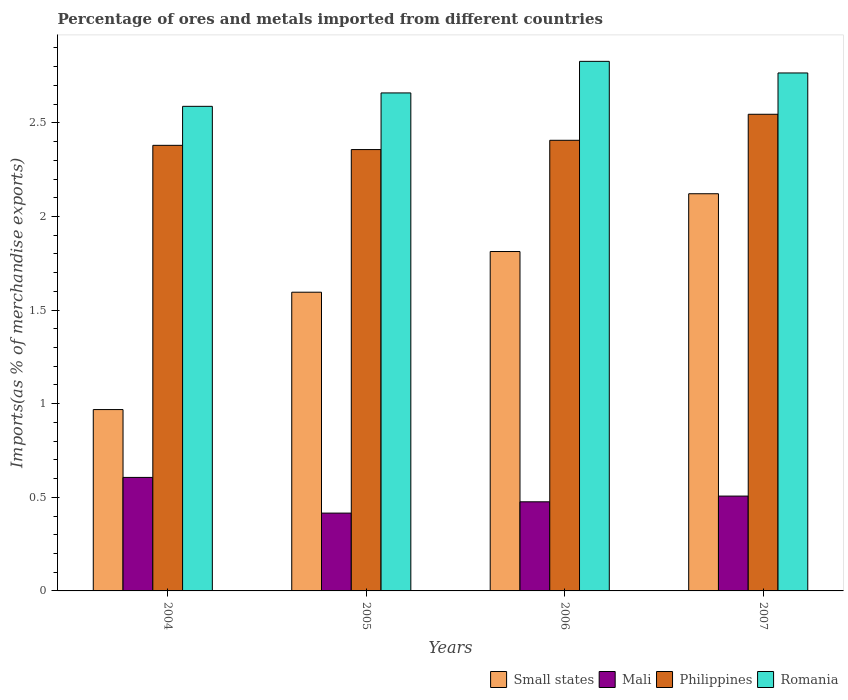How many groups of bars are there?
Ensure brevity in your answer.  4. How many bars are there on the 2nd tick from the left?
Ensure brevity in your answer.  4. What is the percentage of imports to different countries in Small states in 2005?
Ensure brevity in your answer.  1.6. Across all years, what is the maximum percentage of imports to different countries in Philippines?
Give a very brief answer. 2.55. Across all years, what is the minimum percentage of imports to different countries in Romania?
Offer a terse response. 2.59. In which year was the percentage of imports to different countries in Small states maximum?
Provide a succinct answer. 2007. In which year was the percentage of imports to different countries in Mali minimum?
Your answer should be very brief. 2005. What is the total percentage of imports to different countries in Philippines in the graph?
Your answer should be compact. 9.69. What is the difference between the percentage of imports to different countries in Philippines in 2004 and that in 2005?
Provide a succinct answer. 0.02. What is the difference between the percentage of imports to different countries in Small states in 2006 and the percentage of imports to different countries in Mali in 2004?
Provide a succinct answer. 1.21. What is the average percentage of imports to different countries in Mali per year?
Provide a short and direct response. 0.5. In the year 2007, what is the difference between the percentage of imports to different countries in Mali and percentage of imports to different countries in Philippines?
Ensure brevity in your answer.  -2.04. What is the ratio of the percentage of imports to different countries in Romania in 2005 to that in 2006?
Your answer should be compact. 0.94. Is the difference between the percentage of imports to different countries in Mali in 2005 and 2006 greater than the difference between the percentage of imports to different countries in Philippines in 2005 and 2006?
Offer a terse response. No. What is the difference between the highest and the second highest percentage of imports to different countries in Romania?
Offer a very short reply. 0.06. What is the difference between the highest and the lowest percentage of imports to different countries in Mali?
Ensure brevity in your answer.  0.19. Is the sum of the percentage of imports to different countries in Romania in 2004 and 2006 greater than the maximum percentage of imports to different countries in Philippines across all years?
Give a very brief answer. Yes. What does the 1st bar from the left in 2007 represents?
Offer a very short reply. Small states. What does the 3rd bar from the right in 2006 represents?
Make the answer very short. Mali. Is it the case that in every year, the sum of the percentage of imports to different countries in Small states and percentage of imports to different countries in Mali is greater than the percentage of imports to different countries in Romania?
Ensure brevity in your answer.  No. Does the graph contain any zero values?
Provide a succinct answer. No. Does the graph contain grids?
Ensure brevity in your answer.  No. What is the title of the graph?
Provide a short and direct response. Percentage of ores and metals imported from different countries. What is the label or title of the Y-axis?
Ensure brevity in your answer.  Imports(as % of merchandise exports). What is the Imports(as % of merchandise exports) in Small states in 2004?
Your answer should be compact. 0.97. What is the Imports(as % of merchandise exports) in Mali in 2004?
Provide a succinct answer. 0.61. What is the Imports(as % of merchandise exports) in Philippines in 2004?
Offer a terse response. 2.38. What is the Imports(as % of merchandise exports) of Romania in 2004?
Give a very brief answer. 2.59. What is the Imports(as % of merchandise exports) in Small states in 2005?
Offer a terse response. 1.6. What is the Imports(as % of merchandise exports) of Mali in 2005?
Keep it short and to the point. 0.42. What is the Imports(as % of merchandise exports) in Philippines in 2005?
Keep it short and to the point. 2.36. What is the Imports(as % of merchandise exports) of Romania in 2005?
Make the answer very short. 2.66. What is the Imports(as % of merchandise exports) of Small states in 2006?
Your answer should be very brief. 1.81. What is the Imports(as % of merchandise exports) in Mali in 2006?
Your response must be concise. 0.48. What is the Imports(as % of merchandise exports) of Philippines in 2006?
Keep it short and to the point. 2.41. What is the Imports(as % of merchandise exports) of Romania in 2006?
Provide a short and direct response. 2.83. What is the Imports(as % of merchandise exports) in Small states in 2007?
Provide a succinct answer. 2.12. What is the Imports(as % of merchandise exports) in Mali in 2007?
Provide a succinct answer. 0.51. What is the Imports(as % of merchandise exports) of Philippines in 2007?
Ensure brevity in your answer.  2.55. What is the Imports(as % of merchandise exports) in Romania in 2007?
Give a very brief answer. 2.77. Across all years, what is the maximum Imports(as % of merchandise exports) of Small states?
Keep it short and to the point. 2.12. Across all years, what is the maximum Imports(as % of merchandise exports) in Mali?
Provide a short and direct response. 0.61. Across all years, what is the maximum Imports(as % of merchandise exports) in Philippines?
Offer a very short reply. 2.55. Across all years, what is the maximum Imports(as % of merchandise exports) in Romania?
Your response must be concise. 2.83. Across all years, what is the minimum Imports(as % of merchandise exports) of Small states?
Ensure brevity in your answer.  0.97. Across all years, what is the minimum Imports(as % of merchandise exports) of Mali?
Your response must be concise. 0.42. Across all years, what is the minimum Imports(as % of merchandise exports) of Philippines?
Provide a short and direct response. 2.36. Across all years, what is the minimum Imports(as % of merchandise exports) of Romania?
Ensure brevity in your answer.  2.59. What is the total Imports(as % of merchandise exports) of Small states in the graph?
Your response must be concise. 6.5. What is the total Imports(as % of merchandise exports) of Mali in the graph?
Make the answer very short. 2. What is the total Imports(as % of merchandise exports) of Philippines in the graph?
Your answer should be very brief. 9.69. What is the total Imports(as % of merchandise exports) of Romania in the graph?
Make the answer very short. 10.84. What is the difference between the Imports(as % of merchandise exports) of Small states in 2004 and that in 2005?
Provide a short and direct response. -0.63. What is the difference between the Imports(as % of merchandise exports) in Mali in 2004 and that in 2005?
Offer a very short reply. 0.19. What is the difference between the Imports(as % of merchandise exports) in Philippines in 2004 and that in 2005?
Keep it short and to the point. 0.02. What is the difference between the Imports(as % of merchandise exports) of Romania in 2004 and that in 2005?
Provide a succinct answer. -0.07. What is the difference between the Imports(as % of merchandise exports) of Small states in 2004 and that in 2006?
Your response must be concise. -0.84. What is the difference between the Imports(as % of merchandise exports) of Mali in 2004 and that in 2006?
Make the answer very short. 0.13. What is the difference between the Imports(as % of merchandise exports) in Philippines in 2004 and that in 2006?
Offer a very short reply. -0.03. What is the difference between the Imports(as % of merchandise exports) in Romania in 2004 and that in 2006?
Make the answer very short. -0.24. What is the difference between the Imports(as % of merchandise exports) of Small states in 2004 and that in 2007?
Provide a succinct answer. -1.15. What is the difference between the Imports(as % of merchandise exports) in Mali in 2004 and that in 2007?
Offer a very short reply. 0.1. What is the difference between the Imports(as % of merchandise exports) in Philippines in 2004 and that in 2007?
Offer a terse response. -0.17. What is the difference between the Imports(as % of merchandise exports) of Romania in 2004 and that in 2007?
Give a very brief answer. -0.18. What is the difference between the Imports(as % of merchandise exports) of Small states in 2005 and that in 2006?
Offer a very short reply. -0.22. What is the difference between the Imports(as % of merchandise exports) in Mali in 2005 and that in 2006?
Provide a succinct answer. -0.06. What is the difference between the Imports(as % of merchandise exports) of Philippines in 2005 and that in 2006?
Your response must be concise. -0.05. What is the difference between the Imports(as % of merchandise exports) of Romania in 2005 and that in 2006?
Provide a succinct answer. -0.17. What is the difference between the Imports(as % of merchandise exports) in Small states in 2005 and that in 2007?
Ensure brevity in your answer.  -0.53. What is the difference between the Imports(as % of merchandise exports) of Mali in 2005 and that in 2007?
Offer a very short reply. -0.09. What is the difference between the Imports(as % of merchandise exports) of Philippines in 2005 and that in 2007?
Ensure brevity in your answer.  -0.19. What is the difference between the Imports(as % of merchandise exports) of Romania in 2005 and that in 2007?
Give a very brief answer. -0.11. What is the difference between the Imports(as % of merchandise exports) of Small states in 2006 and that in 2007?
Make the answer very short. -0.31. What is the difference between the Imports(as % of merchandise exports) in Mali in 2006 and that in 2007?
Provide a succinct answer. -0.03. What is the difference between the Imports(as % of merchandise exports) in Philippines in 2006 and that in 2007?
Your response must be concise. -0.14. What is the difference between the Imports(as % of merchandise exports) in Romania in 2006 and that in 2007?
Offer a terse response. 0.06. What is the difference between the Imports(as % of merchandise exports) in Small states in 2004 and the Imports(as % of merchandise exports) in Mali in 2005?
Your answer should be compact. 0.55. What is the difference between the Imports(as % of merchandise exports) of Small states in 2004 and the Imports(as % of merchandise exports) of Philippines in 2005?
Your response must be concise. -1.39. What is the difference between the Imports(as % of merchandise exports) in Small states in 2004 and the Imports(as % of merchandise exports) in Romania in 2005?
Provide a short and direct response. -1.69. What is the difference between the Imports(as % of merchandise exports) of Mali in 2004 and the Imports(as % of merchandise exports) of Philippines in 2005?
Keep it short and to the point. -1.75. What is the difference between the Imports(as % of merchandise exports) in Mali in 2004 and the Imports(as % of merchandise exports) in Romania in 2005?
Give a very brief answer. -2.05. What is the difference between the Imports(as % of merchandise exports) of Philippines in 2004 and the Imports(as % of merchandise exports) of Romania in 2005?
Make the answer very short. -0.28. What is the difference between the Imports(as % of merchandise exports) in Small states in 2004 and the Imports(as % of merchandise exports) in Mali in 2006?
Your response must be concise. 0.49. What is the difference between the Imports(as % of merchandise exports) of Small states in 2004 and the Imports(as % of merchandise exports) of Philippines in 2006?
Your response must be concise. -1.44. What is the difference between the Imports(as % of merchandise exports) of Small states in 2004 and the Imports(as % of merchandise exports) of Romania in 2006?
Your answer should be compact. -1.86. What is the difference between the Imports(as % of merchandise exports) in Mali in 2004 and the Imports(as % of merchandise exports) in Philippines in 2006?
Keep it short and to the point. -1.8. What is the difference between the Imports(as % of merchandise exports) in Mali in 2004 and the Imports(as % of merchandise exports) in Romania in 2006?
Give a very brief answer. -2.22. What is the difference between the Imports(as % of merchandise exports) of Philippines in 2004 and the Imports(as % of merchandise exports) of Romania in 2006?
Your answer should be compact. -0.45. What is the difference between the Imports(as % of merchandise exports) in Small states in 2004 and the Imports(as % of merchandise exports) in Mali in 2007?
Your response must be concise. 0.46. What is the difference between the Imports(as % of merchandise exports) in Small states in 2004 and the Imports(as % of merchandise exports) in Philippines in 2007?
Provide a succinct answer. -1.58. What is the difference between the Imports(as % of merchandise exports) in Small states in 2004 and the Imports(as % of merchandise exports) in Romania in 2007?
Give a very brief answer. -1.8. What is the difference between the Imports(as % of merchandise exports) in Mali in 2004 and the Imports(as % of merchandise exports) in Philippines in 2007?
Provide a short and direct response. -1.94. What is the difference between the Imports(as % of merchandise exports) of Mali in 2004 and the Imports(as % of merchandise exports) of Romania in 2007?
Ensure brevity in your answer.  -2.16. What is the difference between the Imports(as % of merchandise exports) in Philippines in 2004 and the Imports(as % of merchandise exports) in Romania in 2007?
Your answer should be compact. -0.39. What is the difference between the Imports(as % of merchandise exports) of Small states in 2005 and the Imports(as % of merchandise exports) of Mali in 2006?
Keep it short and to the point. 1.12. What is the difference between the Imports(as % of merchandise exports) in Small states in 2005 and the Imports(as % of merchandise exports) in Philippines in 2006?
Your response must be concise. -0.81. What is the difference between the Imports(as % of merchandise exports) in Small states in 2005 and the Imports(as % of merchandise exports) in Romania in 2006?
Provide a succinct answer. -1.23. What is the difference between the Imports(as % of merchandise exports) of Mali in 2005 and the Imports(as % of merchandise exports) of Philippines in 2006?
Give a very brief answer. -1.99. What is the difference between the Imports(as % of merchandise exports) of Mali in 2005 and the Imports(as % of merchandise exports) of Romania in 2006?
Ensure brevity in your answer.  -2.41. What is the difference between the Imports(as % of merchandise exports) in Philippines in 2005 and the Imports(as % of merchandise exports) in Romania in 2006?
Offer a very short reply. -0.47. What is the difference between the Imports(as % of merchandise exports) in Small states in 2005 and the Imports(as % of merchandise exports) in Mali in 2007?
Make the answer very short. 1.09. What is the difference between the Imports(as % of merchandise exports) of Small states in 2005 and the Imports(as % of merchandise exports) of Philippines in 2007?
Offer a very short reply. -0.95. What is the difference between the Imports(as % of merchandise exports) of Small states in 2005 and the Imports(as % of merchandise exports) of Romania in 2007?
Give a very brief answer. -1.17. What is the difference between the Imports(as % of merchandise exports) in Mali in 2005 and the Imports(as % of merchandise exports) in Philippines in 2007?
Provide a succinct answer. -2.13. What is the difference between the Imports(as % of merchandise exports) of Mali in 2005 and the Imports(as % of merchandise exports) of Romania in 2007?
Provide a short and direct response. -2.35. What is the difference between the Imports(as % of merchandise exports) in Philippines in 2005 and the Imports(as % of merchandise exports) in Romania in 2007?
Your answer should be compact. -0.41. What is the difference between the Imports(as % of merchandise exports) of Small states in 2006 and the Imports(as % of merchandise exports) of Mali in 2007?
Your response must be concise. 1.31. What is the difference between the Imports(as % of merchandise exports) in Small states in 2006 and the Imports(as % of merchandise exports) in Philippines in 2007?
Offer a very short reply. -0.73. What is the difference between the Imports(as % of merchandise exports) in Small states in 2006 and the Imports(as % of merchandise exports) in Romania in 2007?
Your answer should be compact. -0.95. What is the difference between the Imports(as % of merchandise exports) in Mali in 2006 and the Imports(as % of merchandise exports) in Philippines in 2007?
Your answer should be very brief. -2.07. What is the difference between the Imports(as % of merchandise exports) in Mali in 2006 and the Imports(as % of merchandise exports) in Romania in 2007?
Give a very brief answer. -2.29. What is the difference between the Imports(as % of merchandise exports) in Philippines in 2006 and the Imports(as % of merchandise exports) in Romania in 2007?
Your answer should be very brief. -0.36. What is the average Imports(as % of merchandise exports) of Small states per year?
Your answer should be compact. 1.62. What is the average Imports(as % of merchandise exports) of Mali per year?
Your answer should be compact. 0.5. What is the average Imports(as % of merchandise exports) of Philippines per year?
Keep it short and to the point. 2.42. What is the average Imports(as % of merchandise exports) of Romania per year?
Keep it short and to the point. 2.71. In the year 2004, what is the difference between the Imports(as % of merchandise exports) of Small states and Imports(as % of merchandise exports) of Mali?
Your answer should be compact. 0.36. In the year 2004, what is the difference between the Imports(as % of merchandise exports) in Small states and Imports(as % of merchandise exports) in Philippines?
Your answer should be compact. -1.41. In the year 2004, what is the difference between the Imports(as % of merchandise exports) of Small states and Imports(as % of merchandise exports) of Romania?
Offer a very short reply. -1.62. In the year 2004, what is the difference between the Imports(as % of merchandise exports) in Mali and Imports(as % of merchandise exports) in Philippines?
Ensure brevity in your answer.  -1.77. In the year 2004, what is the difference between the Imports(as % of merchandise exports) in Mali and Imports(as % of merchandise exports) in Romania?
Provide a succinct answer. -1.98. In the year 2004, what is the difference between the Imports(as % of merchandise exports) in Philippines and Imports(as % of merchandise exports) in Romania?
Offer a terse response. -0.21. In the year 2005, what is the difference between the Imports(as % of merchandise exports) of Small states and Imports(as % of merchandise exports) of Mali?
Offer a terse response. 1.18. In the year 2005, what is the difference between the Imports(as % of merchandise exports) in Small states and Imports(as % of merchandise exports) in Philippines?
Keep it short and to the point. -0.76. In the year 2005, what is the difference between the Imports(as % of merchandise exports) in Small states and Imports(as % of merchandise exports) in Romania?
Your response must be concise. -1.06. In the year 2005, what is the difference between the Imports(as % of merchandise exports) in Mali and Imports(as % of merchandise exports) in Philippines?
Provide a short and direct response. -1.94. In the year 2005, what is the difference between the Imports(as % of merchandise exports) in Mali and Imports(as % of merchandise exports) in Romania?
Make the answer very short. -2.24. In the year 2005, what is the difference between the Imports(as % of merchandise exports) of Philippines and Imports(as % of merchandise exports) of Romania?
Offer a terse response. -0.3. In the year 2006, what is the difference between the Imports(as % of merchandise exports) of Small states and Imports(as % of merchandise exports) of Mali?
Provide a short and direct response. 1.34. In the year 2006, what is the difference between the Imports(as % of merchandise exports) in Small states and Imports(as % of merchandise exports) in Philippines?
Your response must be concise. -0.59. In the year 2006, what is the difference between the Imports(as % of merchandise exports) of Small states and Imports(as % of merchandise exports) of Romania?
Give a very brief answer. -1.02. In the year 2006, what is the difference between the Imports(as % of merchandise exports) in Mali and Imports(as % of merchandise exports) in Philippines?
Provide a short and direct response. -1.93. In the year 2006, what is the difference between the Imports(as % of merchandise exports) of Mali and Imports(as % of merchandise exports) of Romania?
Ensure brevity in your answer.  -2.35. In the year 2006, what is the difference between the Imports(as % of merchandise exports) in Philippines and Imports(as % of merchandise exports) in Romania?
Your answer should be very brief. -0.42. In the year 2007, what is the difference between the Imports(as % of merchandise exports) in Small states and Imports(as % of merchandise exports) in Mali?
Give a very brief answer. 1.61. In the year 2007, what is the difference between the Imports(as % of merchandise exports) in Small states and Imports(as % of merchandise exports) in Philippines?
Ensure brevity in your answer.  -0.42. In the year 2007, what is the difference between the Imports(as % of merchandise exports) in Small states and Imports(as % of merchandise exports) in Romania?
Give a very brief answer. -0.65. In the year 2007, what is the difference between the Imports(as % of merchandise exports) of Mali and Imports(as % of merchandise exports) of Philippines?
Give a very brief answer. -2.04. In the year 2007, what is the difference between the Imports(as % of merchandise exports) of Mali and Imports(as % of merchandise exports) of Romania?
Ensure brevity in your answer.  -2.26. In the year 2007, what is the difference between the Imports(as % of merchandise exports) in Philippines and Imports(as % of merchandise exports) in Romania?
Offer a very short reply. -0.22. What is the ratio of the Imports(as % of merchandise exports) of Small states in 2004 to that in 2005?
Make the answer very short. 0.61. What is the ratio of the Imports(as % of merchandise exports) in Mali in 2004 to that in 2005?
Offer a very short reply. 1.46. What is the ratio of the Imports(as % of merchandise exports) of Philippines in 2004 to that in 2005?
Make the answer very short. 1.01. What is the ratio of the Imports(as % of merchandise exports) in Romania in 2004 to that in 2005?
Provide a short and direct response. 0.97. What is the ratio of the Imports(as % of merchandise exports) of Small states in 2004 to that in 2006?
Ensure brevity in your answer.  0.53. What is the ratio of the Imports(as % of merchandise exports) in Mali in 2004 to that in 2006?
Give a very brief answer. 1.27. What is the ratio of the Imports(as % of merchandise exports) in Philippines in 2004 to that in 2006?
Your response must be concise. 0.99. What is the ratio of the Imports(as % of merchandise exports) in Romania in 2004 to that in 2006?
Your answer should be very brief. 0.92. What is the ratio of the Imports(as % of merchandise exports) of Small states in 2004 to that in 2007?
Provide a succinct answer. 0.46. What is the ratio of the Imports(as % of merchandise exports) of Mali in 2004 to that in 2007?
Your answer should be very brief. 1.2. What is the ratio of the Imports(as % of merchandise exports) in Philippines in 2004 to that in 2007?
Ensure brevity in your answer.  0.93. What is the ratio of the Imports(as % of merchandise exports) of Romania in 2004 to that in 2007?
Make the answer very short. 0.94. What is the ratio of the Imports(as % of merchandise exports) of Small states in 2005 to that in 2006?
Offer a terse response. 0.88. What is the ratio of the Imports(as % of merchandise exports) of Mali in 2005 to that in 2006?
Your response must be concise. 0.87. What is the ratio of the Imports(as % of merchandise exports) of Philippines in 2005 to that in 2006?
Your answer should be compact. 0.98. What is the ratio of the Imports(as % of merchandise exports) of Romania in 2005 to that in 2006?
Your answer should be very brief. 0.94. What is the ratio of the Imports(as % of merchandise exports) in Small states in 2005 to that in 2007?
Give a very brief answer. 0.75. What is the ratio of the Imports(as % of merchandise exports) of Mali in 2005 to that in 2007?
Provide a succinct answer. 0.82. What is the ratio of the Imports(as % of merchandise exports) of Philippines in 2005 to that in 2007?
Ensure brevity in your answer.  0.93. What is the ratio of the Imports(as % of merchandise exports) in Romania in 2005 to that in 2007?
Ensure brevity in your answer.  0.96. What is the ratio of the Imports(as % of merchandise exports) of Small states in 2006 to that in 2007?
Offer a terse response. 0.85. What is the ratio of the Imports(as % of merchandise exports) of Mali in 2006 to that in 2007?
Ensure brevity in your answer.  0.94. What is the ratio of the Imports(as % of merchandise exports) of Philippines in 2006 to that in 2007?
Give a very brief answer. 0.95. What is the ratio of the Imports(as % of merchandise exports) in Romania in 2006 to that in 2007?
Your answer should be very brief. 1.02. What is the difference between the highest and the second highest Imports(as % of merchandise exports) of Small states?
Ensure brevity in your answer.  0.31. What is the difference between the highest and the second highest Imports(as % of merchandise exports) of Mali?
Give a very brief answer. 0.1. What is the difference between the highest and the second highest Imports(as % of merchandise exports) in Philippines?
Ensure brevity in your answer.  0.14. What is the difference between the highest and the second highest Imports(as % of merchandise exports) in Romania?
Offer a very short reply. 0.06. What is the difference between the highest and the lowest Imports(as % of merchandise exports) in Small states?
Offer a terse response. 1.15. What is the difference between the highest and the lowest Imports(as % of merchandise exports) of Mali?
Provide a short and direct response. 0.19. What is the difference between the highest and the lowest Imports(as % of merchandise exports) of Philippines?
Your response must be concise. 0.19. What is the difference between the highest and the lowest Imports(as % of merchandise exports) of Romania?
Your answer should be very brief. 0.24. 